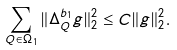<formula> <loc_0><loc_0><loc_500><loc_500>\sum _ { Q \in \Omega _ { 1 } } \| \Delta ^ { b _ { 1 } } _ { Q } g \| ^ { 2 } _ { 2 } \leq C \| g \| ^ { 2 } _ { 2 } .</formula> 